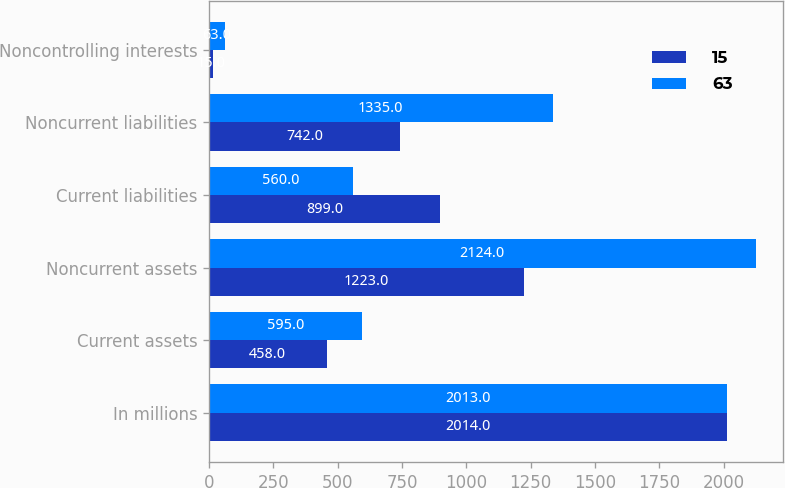<chart> <loc_0><loc_0><loc_500><loc_500><stacked_bar_chart><ecel><fcel>In millions<fcel>Current assets<fcel>Noncurrent assets<fcel>Current liabilities<fcel>Noncurrent liabilities<fcel>Noncontrolling interests<nl><fcel>15<fcel>2014<fcel>458<fcel>1223<fcel>899<fcel>742<fcel>15<nl><fcel>63<fcel>2013<fcel>595<fcel>2124<fcel>560<fcel>1335<fcel>63<nl></chart> 